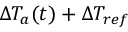Convert formula to latex. <formula><loc_0><loc_0><loc_500><loc_500>\Delta T _ { a } ( t ) + \Delta T _ { r e f }</formula> 